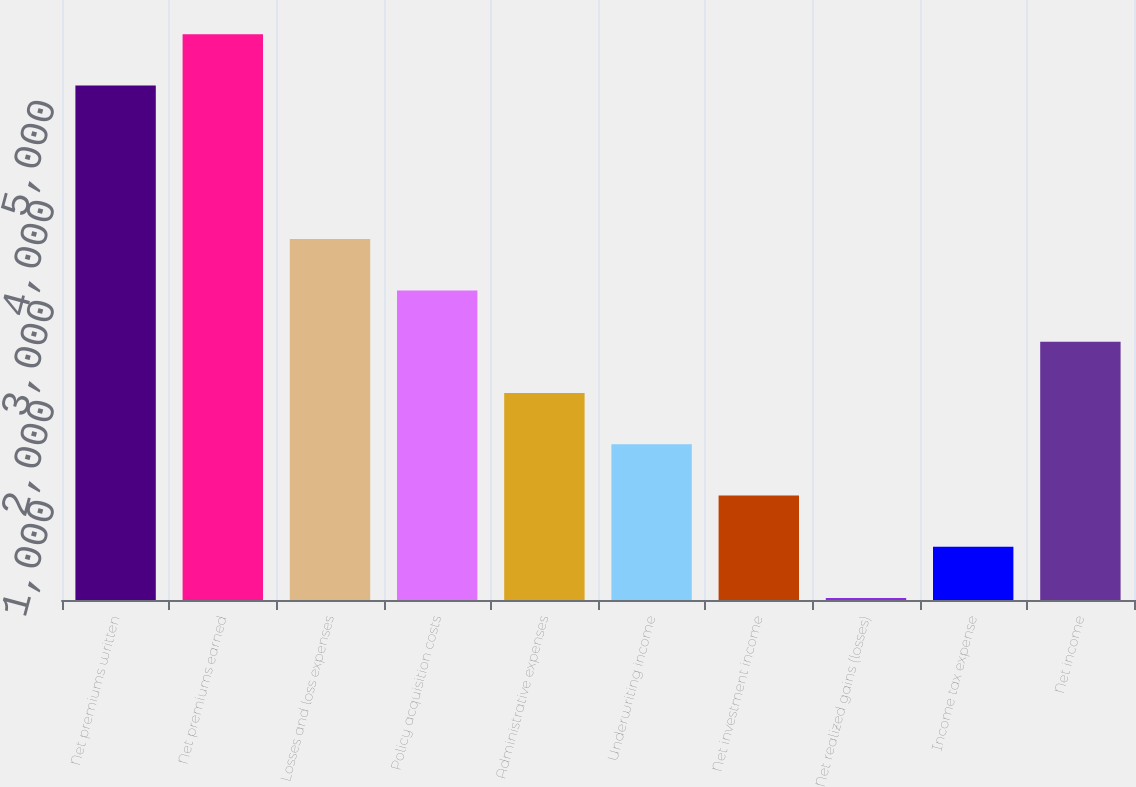Convert chart to OTSL. <chart><loc_0><loc_0><loc_500><loc_500><bar_chart><fcel>Net premiums written<fcel>Net premiums earned<fcel>Losses and loss expenses<fcel>Policy acquisition costs<fcel>Administrative expenses<fcel>Underwriting income<fcel>Net investment income<fcel>Net realized gains (losses)<fcel>Income tax expense<fcel>Net income<nl><fcel>5145<fcel>5657.7<fcel>3608.9<fcel>3096.2<fcel>2070.8<fcel>1558.1<fcel>1045.4<fcel>20<fcel>532.7<fcel>2583.5<nl></chart> 